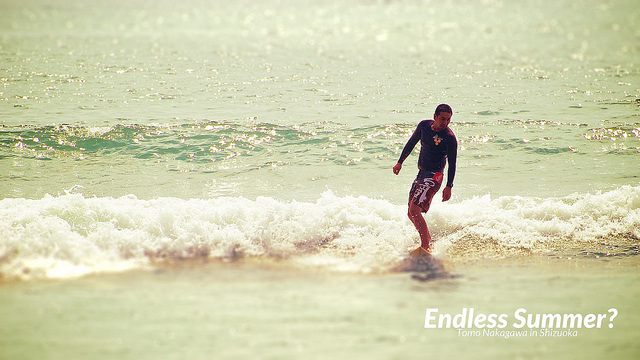Please transcribe the text in this image. Endless Summer Tomo Nakagawa in Shizuaka 